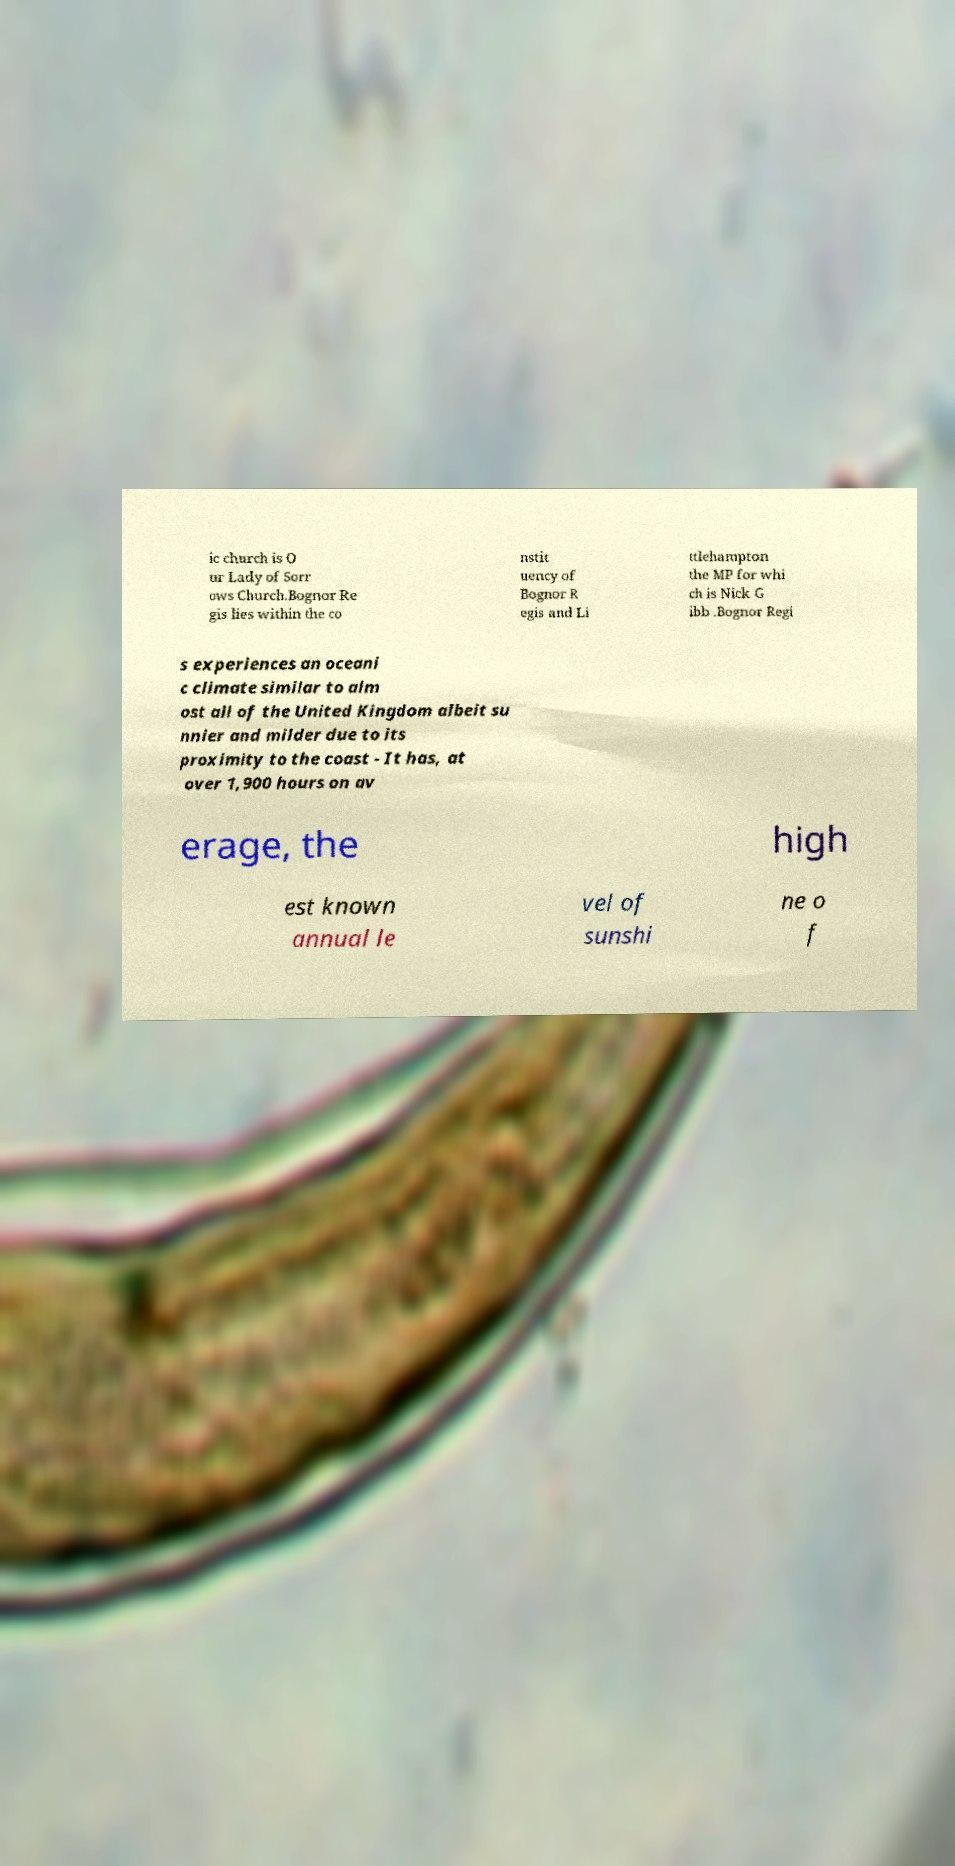Could you assist in decoding the text presented in this image and type it out clearly? ic church is O ur Lady of Sorr ows Church.Bognor Re gis lies within the co nstit uency of Bognor R egis and Li ttlehampton the MP for whi ch is Nick G ibb .Bognor Regi s experiences an oceani c climate similar to alm ost all of the United Kingdom albeit su nnier and milder due to its proximity to the coast - It has, at over 1,900 hours on av erage, the high est known annual le vel of sunshi ne o f 